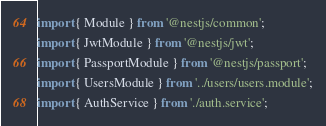Convert code to text. <code><loc_0><loc_0><loc_500><loc_500><_TypeScript_>import { Module } from '@nestjs/common';
import { JwtModule } from '@nestjs/jwt';
import { PassportModule } from '@nestjs/passport';
import { UsersModule } from '../users/users.module';
import { AuthService } from './auth.service';</code> 